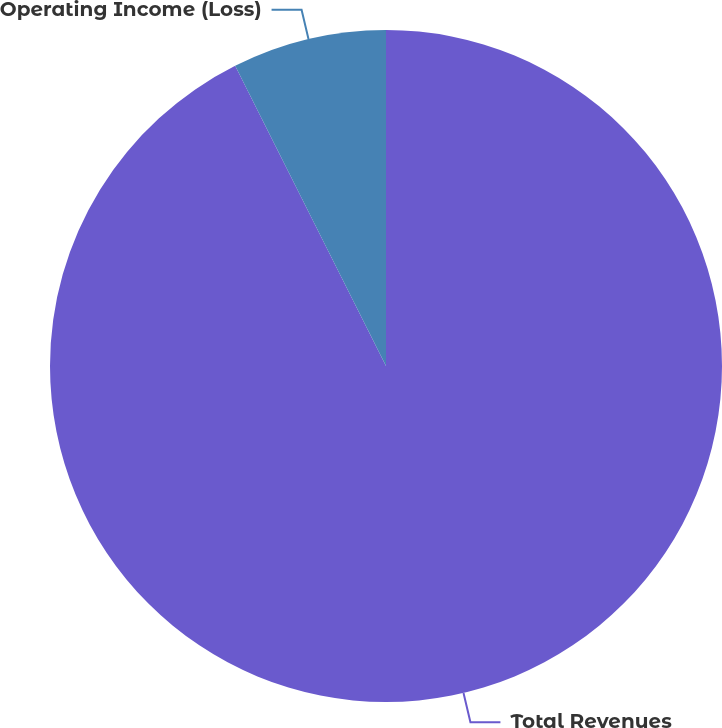Convert chart. <chart><loc_0><loc_0><loc_500><loc_500><pie_chart><fcel>Total Revenues<fcel>Operating Income (Loss)<nl><fcel>92.59%<fcel>7.41%<nl></chart> 